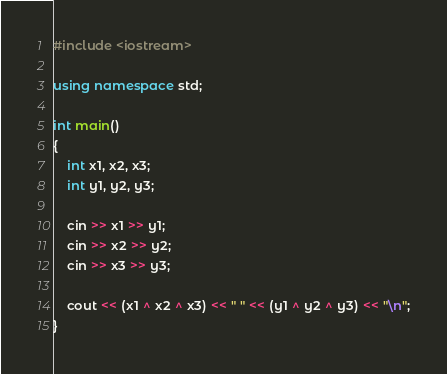Convert code to text. <code><loc_0><loc_0><loc_500><loc_500><_C++_>#include <iostream>

using namespace std;

int main()
{
    int x1, x2, x3;
    int y1, y2, y3;

    cin >> x1 >> y1;
    cin >> x2 >> y2;
    cin >> x3 >> y3;

    cout << (x1 ^ x2 ^ x3) << " " << (y1 ^ y2 ^ y3) << "\n";
}
</code> 